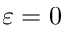Convert formula to latex. <formula><loc_0><loc_0><loc_500><loc_500>\varepsilon = 0</formula> 